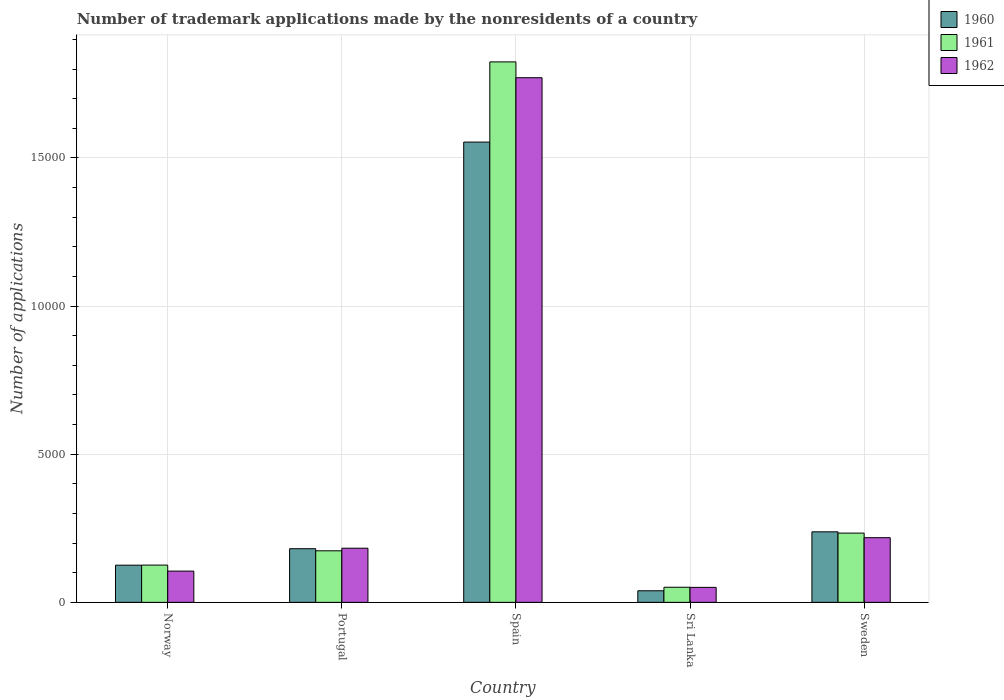How many groups of bars are there?
Provide a short and direct response. 5. Are the number of bars on each tick of the X-axis equal?
Make the answer very short. Yes. How many bars are there on the 2nd tick from the right?
Offer a terse response. 3. In how many cases, is the number of bars for a given country not equal to the number of legend labels?
Keep it short and to the point. 0. What is the number of trademark applications made by the nonresidents in 1960 in Spain?
Offer a very short reply. 1.55e+04. Across all countries, what is the maximum number of trademark applications made by the nonresidents in 1961?
Provide a short and direct response. 1.82e+04. Across all countries, what is the minimum number of trademark applications made by the nonresidents in 1962?
Make the answer very short. 506. In which country was the number of trademark applications made by the nonresidents in 1962 maximum?
Offer a terse response. Spain. In which country was the number of trademark applications made by the nonresidents in 1962 minimum?
Give a very brief answer. Sri Lanka. What is the total number of trademark applications made by the nonresidents in 1961 in the graph?
Your answer should be very brief. 2.41e+04. What is the difference between the number of trademark applications made by the nonresidents in 1962 in Sri Lanka and that in Sweden?
Offer a terse response. -1677. What is the difference between the number of trademark applications made by the nonresidents in 1962 in Sweden and the number of trademark applications made by the nonresidents in 1961 in Sri Lanka?
Your answer should be very brief. 1673. What is the average number of trademark applications made by the nonresidents in 1962 per country?
Provide a short and direct response. 4656.4. What is the difference between the number of trademark applications made by the nonresidents of/in 1961 and number of trademark applications made by the nonresidents of/in 1960 in Spain?
Offer a terse response. 2707. In how many countries, is the number of trademark applications made by the nonresidents in 1961 greater than 2000?
Your answer should be very brief. 2. What is the ratio of the number of trademark applications made by the nonresidents in 1962 in Norway to that in Sweden?
Offer a very short reply. 0.48. Is the number of trademark applications made by the nonresidents in 1961 in Portugal less than that in Sri Lanka?
Ensure brevity in your answer.  No. What is the difference between the highest and the second highest number of trademark applications made by the nonresidents in 1960?
Make the answer very short. 1.37e+04. What is the difference between the highest and the lowest number of trademark applications made by the nonresidents in 1962?
Your answer should be compact. 1.72e+04. Is the sum of the number of trademark applications made by the nonresidents in 1960 in Sri Lanka and Sweden greater than the maximum number of trademark applications made by the nonresidents in 1961 across all countries?
Your answer should be very brief. No. Are all the bars in the graph horizontal?
Your answer should be very brief. No. How many countries are there in the graph?
Provide a succinct answer. 5. What is the difference between two consecutive major ticks on the Y-axis?
Make the answer very short. 5000. Where does the legend appear in the graph?
Ensure brevity in your answer.  Top right. How are the legend labels stacked?
Your answer should be very brief. Vertical. What is the title of the graph?
Give a very brief answer. Number of trademark applications made by the nonresidents of a country. What is the label or title of the Y-axis?
Your answer should be compact. Number of applications. What is the Number of applications of 1960 in Norway?
Give a very brief answer. 1255. What is the Number of applications of 1961 in Norway?
Ensure brevity in your answer.  1258. What is the Number of applications in 1962 in Norway?
Keep it short and to the point. 1055. What is the Number of applications of 1960 in Portugal?
Provide a succinct answer. 1811. What is the Number of applications of 1961 in Portugal?
Your answer should be very brief. 1740. What is the Number of applications in 1962 in Portugal?
Your answer should be compact. 1828. What is the Number of applications of 1960 in Spain?
Your answer should be very brief. 1.55e+04. What is the Number of applications in 1961 in Spain?
Give a very brief answer. 1.82e+04. What is the Number of applications of 1962 in Spain?
Keep it short and to the point. 1.77e+04. What is the Number of applications in 1960 in Sri Lanka?
Ensure brevity in your answer.  391. What is the Number of applications of 1961 in Sri Lanka?
Provide a short and direct response. 510. What is the Number of applications of 1962 in Sri Lanka?
Your answer should be very brief. 506. What is the Number of applications of 1960 in Sweden?
Make the answer very short. 2381. What is the Number of applications in 1961 in Sweden?
Give a very brief answer. 2338. What is the Number of applications in 1962 in Sweden?
Provide a short and direct response. 2183. Across all countries, what is the maximum Number of applications in 1960?
Give a very brief answer. 1.55e+04. Across all countries, what is the maximum Number of applications of 1961?
Ensure brevity in your answer.  1.82e+04. Across all countries, what is the maximum Number of applications in 1962?
Your answer should be compact. 1.77e+04. Across all countries, what is the minimum Number of applications of 1960?
Your answer should be compact. 391. Across all countries, what is the minimum Number of applications in 1961?
Your answer should be compact. 510. Across all countries, what is the minimum Number of applications in 1962?
Offer a terse response. 506. What is the total Number of applications of 1960 in the graph?
Make the answer very short. 2.14e+04. What is the total Number of applications in 1961 in the graph?
Your response must be concise. 2.41e+04. What is the total Number of applications of 1962 in the graph?
Your answer should be compact. 2.33e+04. What is the difference between the Number of applications in 1960 in Norway and that in Portugal?
Offer a terse response. -556. What is the difference between the Number of applications in 1961 in Norway and that in Portugal?
Make the answer very short. -482. What is the difference between the Number of applications in 1962 in Norway and that in Portugal?
Give a very brief answer. -773. What is the difference between the Number of applications in 1960 in Norway and that in Spain?
Your answer should be very brief. -1.43e+04. What is the difference between the Number of applications in 1961 in Norway and that in Spain?
Offer a very short reply. -1.70e+04. What is the difference between the Number of applications of 1962 in Norway and that in Spain?
Ensure brevity in your answer.  -1.67e+04. What is the difference between the Number of applications of 1960 in Norway and that in Sri Lanka?
Give a very brief answer. 864. What is the difference between the Number of applications in 1961 in Norway and that in Sri Lanka?
Your answer should be compact. 748. What is the difference between the Number of applications of 1962 in Norway and that in Sri Lanka?
Ensure brevity in your answer.  549. What is the difference between the Number of applications of 1960 in Norway and that in Sweden?
Ensure brevity in your answer.  -1126. What is the difference between the Number of applications of 1961 in Norway and that in Sweden?
Provide a succinct answer. -1080. What is the difference between the Number of applications of 1962 in Norway and that in Sweden?
Keep it short and to the point. -1128. What is the difference between the Number of applications of 1960 in Portugal and that in Spain?
Ensure brevity in your answer.  -1.37e+04. What is the difference between the Number of applications in 1961 in Portugal and that in Spain?
Offer a terse response. -1.65e+04. What is the difference between the Number of applications in 1962 in Portugal and that in Spain?
Your answer should be very brief. -1.59e+04. What is the difference between the Number of applications of 1960 in Portugal and that in Sri Lanka?
Your response must be concise. 1420. What is the difference between the Number of applications of 1961 in Portugal and that in Sri Lanka?
Offer a very short reply. 1230. What is the difference between the Number of applications in 1962 in Portugal and that in Sri Lanka?
Give a very brief answer. 1322. What is the difference between the Number of applications of 1960 in Portugal and that in Sweden?
Your answer should be compact. -570. What is the difference between the Number of applications of 1961 in Portugal and that in Sweden?
Your response must be concise. -598. What is the difference between the Number of applications of 1962 in Portugal and that in Sweden?
Your answer should be compact. -355. What is the difference between the Number of applications in 1960 in Spain and that in Sri Lanka?
Ensure brevity in your answer.  1.51e+04. What is the difference between the Number of applications in 1961 in Spain and that in Sri Lanka?
Offer a very short reply. 1.77e+04. What is the difference between the Number of applications in 1962 in Spain and that in Sri Lanka?
Your answer should be very brief. 1.72e+04. What is the difference between the Number of applications of 1960 in Spain and that in Sweden?
Your answer should be compact. 1.32e+04. What is the difference between the Number of applications in 1961 in Spain and that in Sweden?
Offer a terse response. 1.59e+04. What is the difference between the Number of applications of 1962 in Spain and that in Sweden?
Your response must be concise. 1.55e+04. What is the difference between the Number of applications of 1960 in Sri Lanka and that in Sweden?
Your answer should be compact. -1990. What is the difference between the Number of applications in 1961 in Sri Lanka and that in Sweden?
Make the answer very short. -1828. What is the difference between the Number of applications in 1962 in Sri Lanka and that in Sweden?
Provide a short and direct response. -1677. What is the difference between the Number of applications in 1960 in Norway and the Number of applications in 1961 in Portugal?
Ensure brevity in your answer.  -485. What is the difference between the Number of applications of 1960 in Norway and the Number of applications of 1962 in Portugal?
Offer a very short reply. -573. What is the difference between the Number of applications of 1961 in Norway and the Number of applications of 1962 in Portugal?
Ensure brevity in your answer.  -570. What is the difference between the Number of applications of 1960 in Norway and the Number of applications of 1961 in Spain?
Ensure brevity in your answer.  -1.70e+04. What is the difference between the Number of applications of 1960 in Norway and the Number of applications of 1962 in Spain?
Provide a short and direct response. -1.65e+04. What is the difference between the Number of applications of 1961 in Norway and the Number of applications of 1962 in Spain?
Offer a terse response. -1.65e+04. What is the difference between the Number of applications in 1960 in Norway and the Number of applications in 1961 in Sri Lanka?
Provide a short and direct response. 745. What is the difference between the Number of applications in 1960 in Norway and the Number of applications in 1962 in Sri Lanka?
Provide a short and direct response. 749. What is the difference between the Number of applications in 1961 in Norway and the Number of applications in 1962 in Sri Lanka?
Your answer should be compact. 752. What is the difference between the Number of applications in 1960 in Norway and the Number of applications in 1961 in Sweden?
Make the answer very short. -1083. What is the difference between the Number of applications of 1960 in Norway and the Number of applications of 1962 in Sweden?
Provide a succinct answer. -928. What is the difference between the Number of applications of 1961 in Norway and the Number of applications of 1962 in Sweden?
Your answer should be very brief. -925. What is the difference between the Number of applications of 1960 in Portugal and the Number of applications of 1961 in Spain?
Ensure brevity in your answer.  -1.64e+04. What is the difference between the Number of applications of 1960 in Portugal and the Number of applications of 1962 in Spain?
Offer a terse response. -1.59e+04. What is the difference between the Number of applications in 1961 in Portugal and the Number of applications in 1962 in Spain?
Your answer should be very brief. -1.60e+04. What is the difference between the Number of applications in 1960 in Portugal and the Number of applications in 1961 in Sri Lanka?
Provide a succinct answer. 1301. What is the difference between the Number of applications of 1960 in Portugal and the Number of applications of 1962 in Sri Lanka?
Offer a terse response. 1305. What is the difference between the Number of applications of 1961 in Portugal and the Number of applications of 1962 in Sri Lanka?
Your answer should be very brief. 1234. What is the difference between the Number of applications of 1960 in Portugal and the Number of applications of 1961 in Sweden?
Offer a terse response. -527. What is the difference between the Number of applications of 1960 in Portugal and the Number of applications of 1962 in Sweden?
Keep it short and to the point. -372. What is the difference between the Number of applications of 1961 in Portugal and the Number of applications of 1962 in Sweden?
Your answer should be very brief. -443. What is the difference between the Number of applications in 1960 in Spain and the Number of applications in 1961 in Sri Lanka?
Ensure brevity in your answer.  1.50e+04. What is the difference between the Number of applications of 1960 in Spain and the Number of applications of 1962 in Sri Lanka?
Provide a succinct answer. 1.50e+04. What is the difference between the Number of applications of 1961 in Spain and the Number of applications of 1962 in Sri Lanka?
Provide a short and direct response. 1.77e+04. What is the difference between the Number of applications in 1960 in Spain and the Number of applications in 1961 in Sweden?
Give a very brief answer. 1.32e+04. What is the difference between the Number of applications of 1960 in Spain and the Number of applications of 1962 in Sweden?
Give a very brief answer. 1.34e+04. What is the difference between the Number of applications in 1961 in Spain and the Number of applications in 1962 in Sweden?
Give a very brief answer. 1.61e+04. What is the difference between the Number of applications in 1960 in Sri Lanka and the Number of applications in 1961 in Sweden?
Your response must be concise. -1947. What is the difference between the Number of applications in 1960 in Sri Lanka and the Number of applications in 1962 in Sweden?
Your response must be concise. -1792. What is the difference between the Number of applications of 1961 in Sri Lanka and the Number of applications of 1962 in Sweden?
Offer a very short reply. -1673. What is the average Number of applications in 1960 per country?
Your response must be concise. 4275. What is the average Number of applications in 1961 per country?
Offer a very short reply. 4818. What is the average Number of applications of 1962 per country?
Provide a succinct answer. 4656.4. What is the difference between the Number of applications of 1960 and Number of applications of 1961 in Norway?
Give a very brief answer. -3. What is the difference between the Number of applications in 1960 and Number of applications in 1962 in Norway?
Offer a very short reply. 200. What is the difference between the Number of applications of 1961 and Number of applications of 1962 in Norway?
Your response must be concise. 203. What is the difference between the Number of applications in 1960 and Number of applications in 1961 in Portugal?
Ensure brevity in your answer.  71. What is the difference between the Number of applications of 1960 and Number of applications of 1962 in Portugal?
Give a very brief answer. -17. What is the difference between the Number of applications in 1961 and Number of applications in 1962 in Portugal?
Offer a terse response. -88. What is the difference between the Number of applications of 1960 and Number of applications of 1961 in Spain?
Ensure brevity in your answer.  -2707. What is the difference between the Number of applications in 1960 and Number of applications in 1962 in Spain?
Offer a terse response. -2173. What is the difference between the Number of applications of 1961 and Number of applications of 1962 in Spain?
Your answer should be compact. 534. What is the difference between the Number of applications in 1960 and Number of applications in 1961 in Sri Lanka?
Offer a very short reply. -119. What is the difference between the Number of applications in 1960 and Number of applications in 1962 in Sri Lanka?
Your answer should be compact. -115. What is the difference between the Number of applications of 1961 and Number of applications of 1962 in Sri Lanka?
Offer a very short reply. 4. What is the difference between the Number of applications in 1960 and Number of applications in 1961 in Sweden?
Your answer should be compact. 43. What is the difference between the Number of applications in 1960 and Number of applications in 1962 in Sweden?
Give a very brief answer. 198. What is the difference between the Number of applications in 1961 and Number of applications in 1962 in Sweden?
Give a very brief answer. 155. What is the ratio of the Number of applications in 1960 in Norway to that in Portugal?
Your answer should be very brief. 0.69. What is the ratio of the Number of applications in 1961 in Norway to that in Portugal?
Offer a very short reply. 0.72. What is the ratio of the Number of applications of 1962 in Norway to that in Portugal?
Ensure brevity in your answer.  0.58. What is the ratio of the Number of applications in 1960 in Norway to that in Spain?
Provide a succinct answer. 0.08. What is the ratio of the Number of applications of 1961 in Norway to that in Spain?
Offer a terse response. 0.07. What is the ratio of the Number of applications in 1962 in Norway to that in Spain?
Provide a succinct answer. 0.06. What is the ratio of the Number of applications of 1960 in Norway to that in Sri Lanka?
Provide a short and direct response. 3.21. What is the ratio of the Number of applications of 1961 in Norway to that in Sri Lanka?
Offer a very short reply. 2.47. What is the ratio of the Number of applications in 1962 in Norway to that in Sri Lanka?
Your answer should be very brief. 2.08. What is the ratio of the Number of applications of 1960 in Norway to that in Sweden?
Provide a succinct answer. 0.53. What is the ratio of the Number of applications of 1961 in Norway to that in Sweden?
Give a very brief answer. 0.54. What is the ratio of the Number of applications in 1962 in Norway to that in Sweden?
Make the answer very short. 0.48. What is the ratio of the Number of applications of 1960 in Portugal to that in Spain?
Make the answer very short. 0.12. What is the ratio of the Number of applications in 1961 in Portugal to that in Spain?
Your response must be concise. 0.1. What is the ratio of the Number of applications of 1962 in Portugal to that in Spain?
Provide a short and direct response. 0.1. What is the ratio of the Number of applications in 1960 in Portugal to that in Sri Lanka?
Your answer should be very brief. 4.63. What is the ratio of the Number of applications in 1961 in Portugal to that in Sri Lanka?
Provide a short and direct response. 3.41. What is the ratio of the Number of applications in 1962 in Portugal to that in Sri Lanka?
Keep it short and to the point. 3.61. What is the ratio of the Number of applications in 1960 in Portugal to that in Sweden?
Ensure brevity in your answer.  0.76. What is the ratio of the Number of applications in 1961 in Portugal to that in Sweden?
Your answer should be compact. 0.74. What is the ratio of the Number of applications in 1962 in Portugal to that in Sweden?
Ensure brevity in your answer.  0.84. What is the ratio of the Number of applications in 1960 in Spain to that in Sri Lanka?
Ensure brevity in your answer.  39.74. What is the ratio of the Number of applications in 1961 in Spain to that in Sri Lanka?
Provide a succinct answer. 35.77. What is the ratio of the Number of applications in 1962 in Spain to that in Sri Lanka?
Give a very brief answer. 35. What is the ratio of the Number of applications of 1960 in Spain to that in Sweden?
Your answer should be compact. 6.53. What is the ratio of the Number of applications in 1961 in Spain to that in Sweden?
Provide a short and direct response. 7.8. What is the ratio of the Number of applications of 1962 in Spain to that in Sweden?
Provide a succinct answer. 8.11. What is the ratio of the Number of applications of 1960 in Sri Lanka to that in Sweden?
Offer a very short reply. 0.16. What is the ratio of the Number of applications in 1961 in Sri Lanka to that in Sweden?
Your answer should be compact. 0.22. What is the ratio of the Number of applications of 1962 in Sri Lanka to that in Sweden?
Provide a succinct answer. 0.23. What is the difference between the highest and the second highest Number of applications in 1960?
Make the answer very short. 1.32e+04. What is the difference between the highest and the second highest Number of applications in 1961?
Keep it short and to the point. 1.59e+04. What is the difference between the highest and the second highest Number of applications in 1962?
Ensure brevity in your answer.  1.55e+04. What is the difference between the highest and the lowest Number of applications in 1960?
Your answer should be compact. 1.51e+04. What is the difference between the highest and the lowest Number of applications of 1961?
Your response must be concise. 1.77e+04. What is the difference between the highest and the lowest Number of applications of 1962?
Make the answer very short. 1.72e+04. 